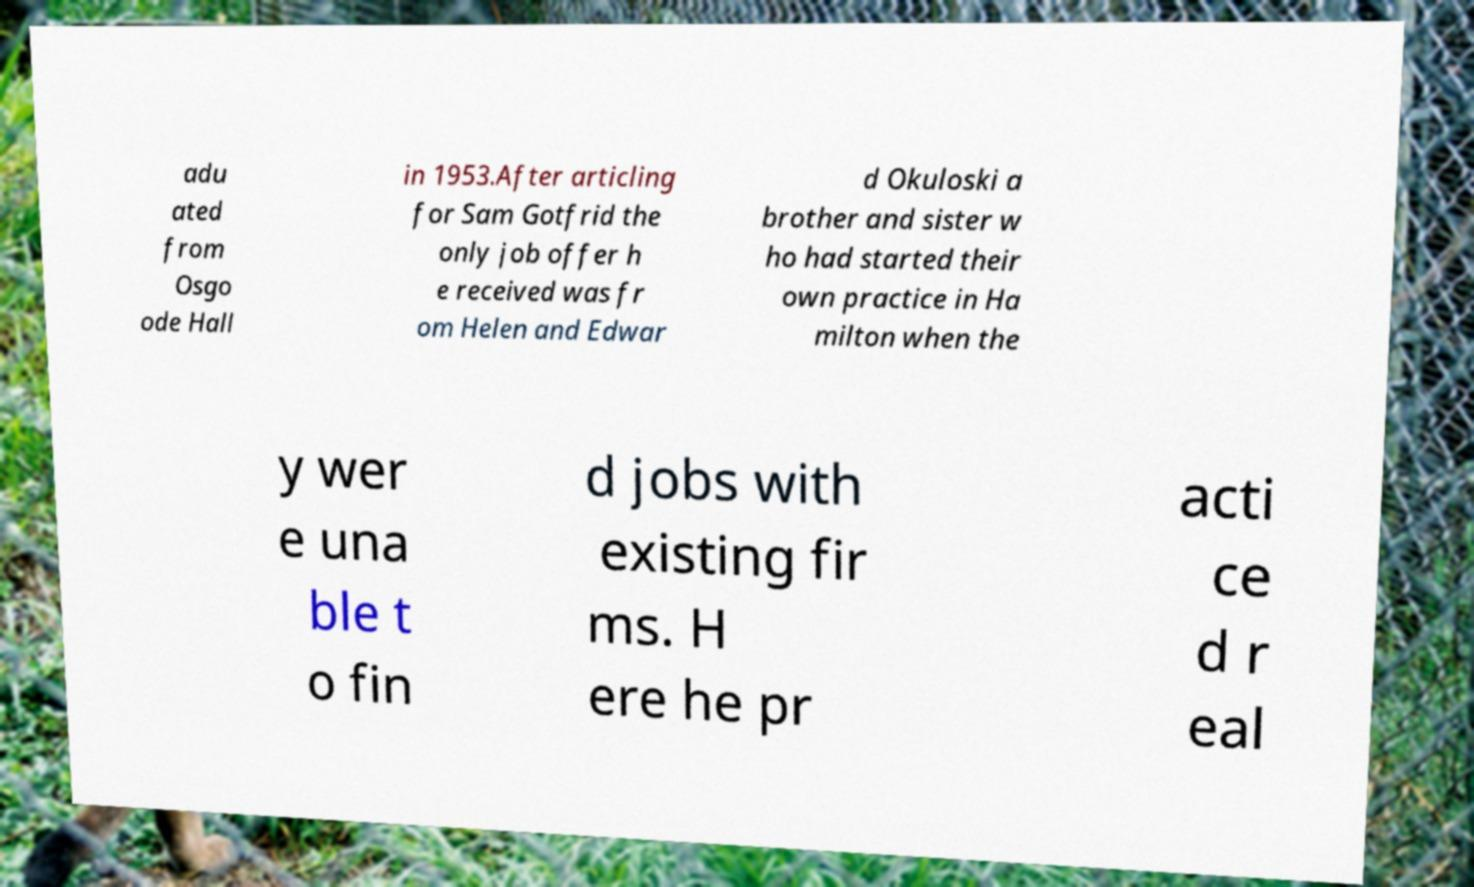Could you assist in decoding the text presented in this image and type it out clearly? adu ated from Osgo ode Hall in 1953.After articling for Sam Gotfrid the only job offer h e received was fr om Helen and Edwar d Okuloski a brother and sister w ho had started their own practice in Ha milton when the y wer e una ble t o fin d jobs with existing fir ms. H ere he pr acti ce d r eal 